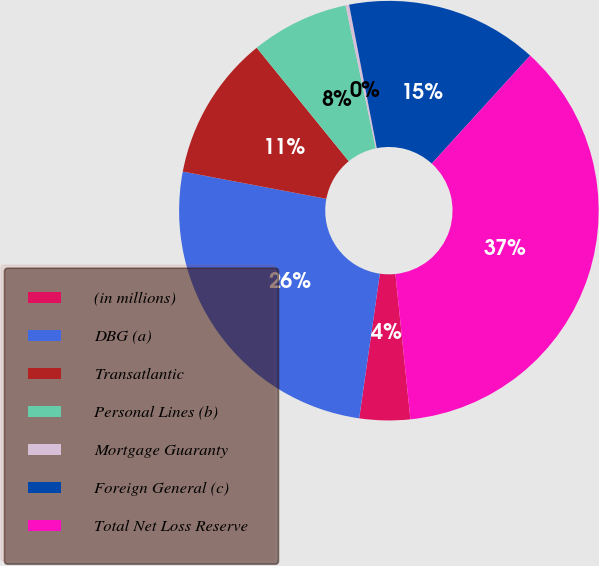Convert chart. <chart><loc_0><loc_0><loc_500><loc_500><pie_chart><fcel>(in millions)<fcel>DBG (a)<fcel>Transatlantic<fcel>Personal Lines (b)<fcel>Mortgage Guaranty<fcel>Foreign General (c)<fcel>Total Net Loss Reserve<nl><fcel>3.9%<fcel>25.72%<fcel>11.17%<fcel>7.54%<fcel>0.27%<fcel>14.8%<fcel>36.6%<nl></chart> 